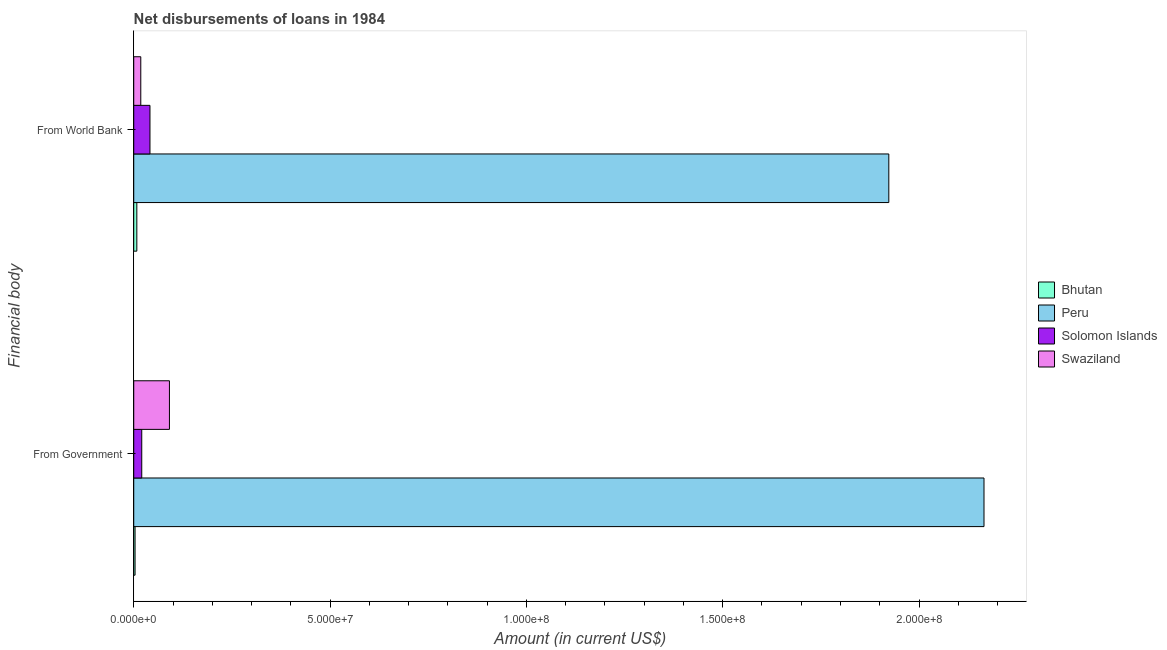Are the number of bars on each tick of the Y-axis equal?
Provide a succinct answer. Yes. How many bars are there on the 2nd tick from the top?
Give a very brief answer. 4. What is the label of the 1st group of bars from the top?
Make the answer very short. From World Bank. What is the net disbursements of loan from government in Peru?
Provide a succinct answer. 2.17e+08. Across all countries, what is the maximum net disbursements of loan from world bank?
Provide a succinct answer. 1.92e+08. Across all countries, what is the minimum net disbursements of loan from world bank?
Your response must be concise. 7.87e+05. In which country was the net disbursements of loan from world bank maximum?
Offer a very short reply. Peru. In which country was the net disbursements of loan from government minimum?
Ensure brevity in your answer.  Bhutan. What is the total net disbursements of loan from world bank in the graph?
Your answer should be very brief. 1.99e+08. What is the difference between the net disbursements of loan from world bank in Swaziland and that in Peru?
Your answer should be very brief. -1.91e+08. What is the difference between the net disbursements of loan from world bank in Swaziland and the net disbursements of loan from government in Bhutan?
Provide a succinct answer. 1.46e+06. What is the average net disbursements of loan from world bank per country?
Your response must be concise. 4.98e+07. What is the difference between the net disbursements of loan from government and net disbursements of loan from world bank in Peru?
Your answer should be compact. 2.42e+07. What is the ratio of the net disbursements of loan from world bank in Swaziland to that in Solomon Islands?
Give a very brief answer. 0.43. In how many countries, is the net disbursements of loan from world bank greater than the average net disbursements of loan from world bank taken over all countries?
Keep it short and to the point. 1. What does the 3rd bar from the top in From Government represents?
Make the answer very short. Peru. What does the 4th bar from the bottom in From World Bank represents?
Give a very brief answer. Swaziland. How many bars are there?
Your answer should be compact. 8. How many countries are there in the graph?
Offer a terse response. 4. Does the graph contain any zero values?
Offer a very short reply. No. Where does the legend appear in the graph?
Provide a short and direct response. Center right. How many legend labels are there?
Ensure brevity in your answer.  4. How are the legend labels stacked?
Make the answer very short. Vertical. What is the title of the graph?
Your answer should be compact. Net disbursements of loans in 1984. Does "Channel Islands" appear as one of the legend labels in the graph?
Your answer should be very brief. No. What is the label or title of the Y-axis?
Ensure brevity in your answer.  Financial body. What is the Amount (in current US$) in Bhutan in From Government?
Give a very brief answer. 3.37e+05. What is the Amount (in current US$) in Peru in From Government?
Provide a short and direct response. 2.17e+08. What is the Amount (in current US$) of Solomon Islands in From Government?
Provide a short and direct response. 2.04e+06. What is the Amount (in current US$) of Swaziland in From Government?
Give a very brief answer. 9.09e+06. What is the Amount (in current US$) of Bhutan in From World Bank?
Keep it short and to the point. 7.87e+05. What is the Amount (in current US$) of Peru in From World Bank?
Give a very brief answer. 1.92e+08. What is the Amount (in current US$) of Solomon Islands in From World Bank?
Your answer should be compact. 4.14e+06. What is the Amount (in current US$) of Swaziland in From World Bank?
Your response must be concise. 1.79e+06. Across all Financial body, what is the maximum Amount (in current US$) of Bhutan?
Ensure brevity in your answer.  7.87e+05. Across all Financial body, what is the maximum Amount (in current US$) in Peru?
Your answer should be compact. 2.17e+08. Across all Financial body, what is the maximum Amount (in current US$) of Solomon Islands?
Give a very brief answer. 4.14e+06. Across all Financial body, what is the maximum Amount (in current US$) in Swaziland?
Make the answer very short. 9.09e+06. Across all Financial body, what is the minimum Amount (in current US$) of Bhutan?
Offer a terse response. 3.37e+05. Across all Financial body, what is the minimum Amount (in current US$) of Peru?
Offer a very short reply. 1.92e+08. Across all Financial body, what is the minimum Amount (in current US$) of Solomon Islands?
Offer a terse response. 2.04e+06. Across all Financial body, what is the minimum Amount (in current US$) of Swaziland?
Keep it short and to the point. 1.79e+06. What is the total Amount (in current US$) in Bhutan in the graph?
Your answer should be very brief. 1.12e+06. What is the total Amount (in current US$) of Peru in the graph?
Ensure brevity in your answer.  4.09e+08. What is the total Amount (in current US$) in Solomon Islands in the graph?
Ensure brevity in your answer.  6.18e+06. What is the total Amount (in current US$) of Swaziland in the graph?
Your answer should be compact. 1.09e+07. What is the difference between the Amount (in current US$) in Bhutan in From Government and that in From World Bank?
Provide a short and direct response. -4.50e+05. What is the difference between the Amount (in current US$) in Peru in From Government and that in From World Bank?
Ensure brevity in your answer.  2.42e+07. What is the difference between the Amount (in current US$) in Solomon Islands in From Government and that in From World Bank?
Make the answer very short. -2.10e+06. What is the difference between the Amount (in current US$) in Swaziland in From Government and that in From World Bank?
Make the answer very short. 7.30e+06. What is the difference between the Amount (in current US$) in Bhutan in From Government and the Amount (in current US$) in Peru in From World Bank?
Your answer should be very brief. -1.92e+08. What is the difference between the Amount (in current US$) in Bhutan in From Government and the Amount (in current US$) in Solomon Islands in From World Bank?
Provide a succinct answer. -3.80e+06. What is the difference between the Amount (in current US$) of Bhutan in From Government and the Amount (in current US$) of Swaziland in From World Bank?
Keep it short and to the point. -1.46e+06. What is the difference between the Amount (in current US$) in Peru in From Government and the Amount (in current US$) in Solomon Islands in From World Bank?
Provide a short and direct response. 2.12e+08. What is the difference between the Amount (in current US$) of Peru in From Government and the Amount (in current US$) of Swaziland in From World Bank?
Give a very brief answer. 2.15e+08. What is the difference between the Amount (in current US$) of Solomon Islands in From Government and the Amount (in current US$) of Swaziland in From World Bank?
Give a very brief answer. 2.46e+05. What is the average Amount (in current US$) of Bhutan per Financial body?
Your response must be concise. 5.62e+05. What is the average Amount (in current US$) in Peru per Financial body?
Your response must be concise. 2.04e+08. What is the average Amount (in current US$) in Solomon Islands per Financial body?
Your response must be concise. 3.09e+06. What is the average Amount (in current US$) in Swaziland per Financial body?
Offer a very short reply. 5.44e+06. What is the difference between the Amount (in current US$) in Bhutan and Amount (in current US$) in Peru in From Government?
Ensure brevity in your answer.  -2.16e+08. What is the difference between the Amount (in current US$) of Bhutan and Amount (in current US$) of Solomon Islands in From Government?
Offer a very short reply. -1.70e+06. What is the difference between the Amount (in current US$) in Bhutan and Amount (in current US$) in Swaziland in From Government?
Offer a terse response. -8.76e+06. What is the difference between the Amount (in current US$) of Peru and Amount (in current US$) of Solomon Islands in From Government?
Your response must be concise. 2.15e+08. What is the difference between the Amount (in current US$) of Peru and Amount (in current US$) of Swaziland in From Government?
Offer a terse response. 2.07e+08. What is the difference between the Amount (in current US$) of Solomon Islands and Amount (in current US$) of Swaziland in From Government?
Your answer should be very brief. -7.05e+06. What is the difference between the Amount (in current US$) in Bhutan and Amount (in current US$) in Peru in From World Bank?
Make the answer very short. -1.92e+08. What is the difference between the Amount (in current US$) in Bhutan and Amount (in current US$) in Solomon Islands in From World Bank?
Your response must be concise. -3.35e+06. What is the difference between the Amount (in current US$) in Bhutan and Amount (in current US$) in Swaziland in From World Bank?
Make the answer very short. -1.01e+06. What is the difference between the Amount (in current US$) of Peru and Amount (in current US$) of Solomon Islands in From World Bank?
Give a very brief answer. 1.88e+08. What is the difference between the Amount (in current US$) in Peru and Amount (in current US$) in Swaziland in From World Bank?
Provide a short and direct response. 1.91e+08. What is the difference between the Amount (in current US$) in Solomon Islands and Amount (in current US$) in Swaziland in From World Bank?
Keep it short and to the point. 2.34e+06. What is the ratio of the Amount (in current US$) in Bhutan in From Government to that in From World Bank?
Keep it short and to the point. 0.43. What is the ratio of the Amount (in current US$) in Peru in From Government to that in From World Bank?
Offer a terse response. 1.13. What is the ratio of the Amount (in current US$) of Solomon Islands in From Government to that in From World Bank?
Provide a succinct answer. 0.49. What is the ratio of the Amount (in current US$) in Swaziland in From Government to that in From World Bank?
Offer a very short reply. 5.07. What is the difference between the highest and the second highest Amount (in current US$) of Bhutan?
Your response must be concise. 4.50e+05. What is the difference between the highest and the second highest Amount (in current US$) of Peru?
Make the answer very short. 2.42e+07. What is the difference between the highest and the second highest Amount (in current US$) of Solomon Islands?
Your answer should be very brief. 2.10e+06. What is the difference between the highest and the second highest Amount (in current US$) in Swaziland?
Your answer should be compact. 7.30e+06. What is the difference between the highest and the lowest Amount (in current US$) in Bhutan?
Provide a short and direct response. 4.50e+05. What is the difference between the highest and the lowest Amount (in current US$) of Peru?
Give a very brief answer. 2.42e+07. What is the difference between the highest and the lowest Amount (in current US$) of Solomon Islands?
Offer a very short reply. 2.10e+06. What is the difference between the highest and the lowest Amount (in current US$) in Swaziland?
Make the answer very short. 7.30e+06. 